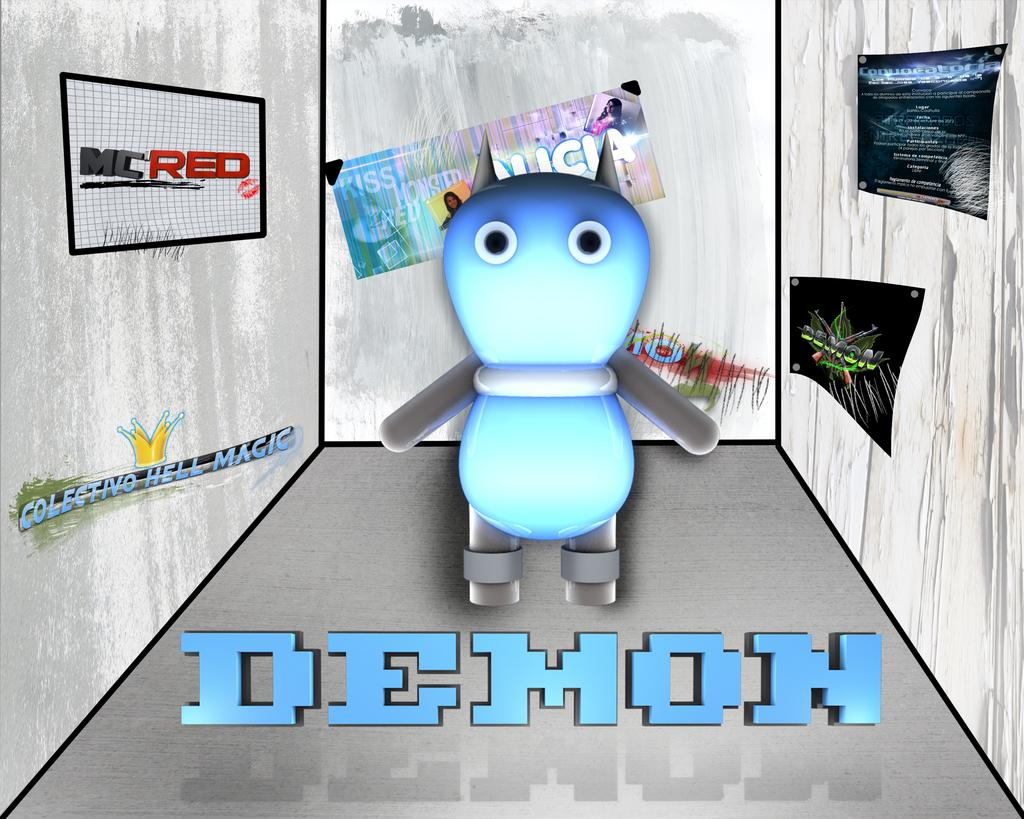What type of image is being described? The image is animated. What can be seen in the animated image? There is a cartoon in the image. What is the cartoon attached to in the image? There are boards attached to a white surface in the image. Is there any text or symbols present in the image? Yes, there is writing on the image. What type of dress is the crook wearing in the image? There is no crook or dress present in the image; it features an animated cartoon with writing on boards attached to a white surface. 